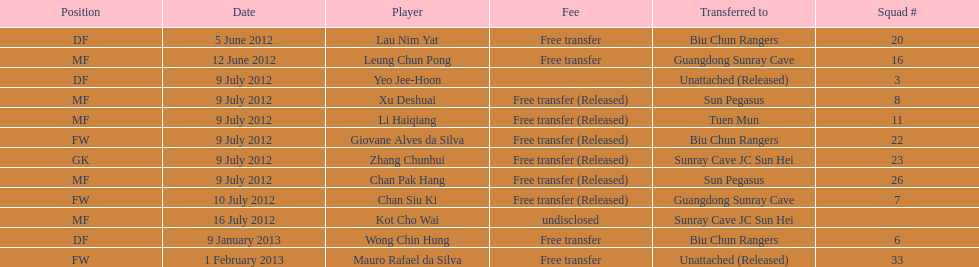How many uninterrupted players were set free on july 9? 6. 